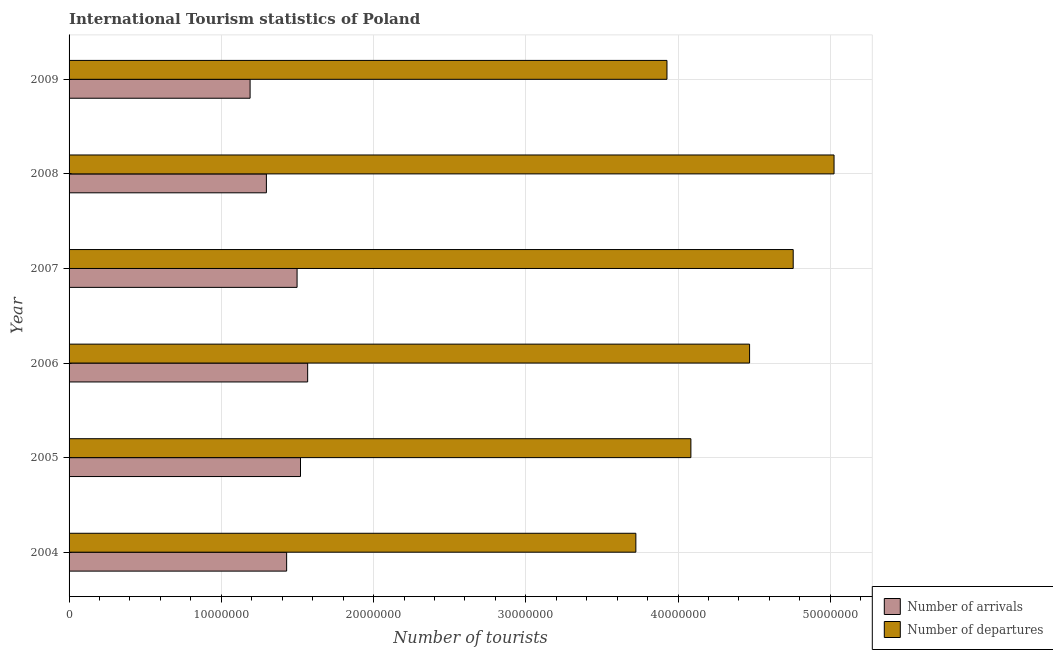How many different coloured bars are there?
Offer a terse response. 2. Are the number of bars on each tick of the Y-axis equal?
Your answer should be very brief. Yes. How many bars are there on the 3rd tick from the top?
Give a very brief answer. 2. What is the number of tourist departures in 2008?
Give a very brief answer. 5.02e+07. Across all years, what is the maximum number of tourist arrivals?
Your answer should be very brief. 1.57e+07. Across all years, what is the minimum number of tourist departures?
Offer a very short reply. 3.72e+07. In which year was the number of tourist arrivals maximum?
Offer a terse response. 2006. In which year was the number of tourist departures minimum?
Your response must be concise. 2004. What is the total number of tourist departures in the graph?
Ensure brevity in your answer.  2.60e+08. What is the difference between the number of tourist arrivals in 2007 and that in 2009?
Offer a very short reply. 3.08e+06. What is the difference between the number of tourist departures in 2008 and the number of tourist arrivals in 2009?
Provide a short and direct response. 3.84e+07. What is the average number of tourist arrivals per year?
Ensure brevity in your answer.  1.42e+07. In the year 2009, what is the difference between the number of tourist arrivals and number of tourist departures?
Offer a very short reply. -2.74e+07. In how many years, is the number of tourist departures greater than 12000000 ?
Make the answer very short. 6. What is the ratio of the number of tourist departures in 2004 to that in 2006?
Provide a short and direct response. 0.83. Is the number of tourist arrivals in 2008 less than that in 2009?
Provide a succinct answer. No. What is the difference between the highest and the second highest number of tourist departures?
Offer a very short reply. 2.68e+06. What is the difference between the highest and the lowest number of tourist arrivals?
Keep it short and to the point. 3.78e+06. Is the sum of the number of tourist departures in 2004 and 2007 greater than the maximum number of tourist arrivals across all years?
Keep it short and to the point. Yes. What does the 1st bar from the top in 2008 represents?
Give a very brief answer. Number of departures. What does the 2nd bar from the bottom in 2009 represents?
Make the answer very short. Number of departures. Are all the bars in the graph horizontal?
Your response must be concise. Yes. How many years are there in the graph?
Ensure brevity in your answer.  6. Are the values on the major ticks of X-axis written in scientific E-notation?
Give a very brief answer. No. Does the graph contain any zero values?
Give a very brief answer. No. Does the graph contain grids?
Make the answer very short. Yes. Where does the legend appear in the graph?
Your answer should be very brief. Bottom right. How many legend labels are there?
Your answer should be very brief. 2. How are the legend labels stacked?
Your answer should be compact. Vertical. What is the title of the graph?
Your response must be concise. International Tourism statistics of Poland. Does "From Government" appear as one of the legend labels in the graph?
Give a very brief answer. No. What is the label or title of the X-axis?
Your answer should be very brief. Number of tourists. What is the Number of tourists in Number of arrivals in 2004?
Offer a very short reply. 1.43e+07. What is the Number of tourists in Number of departures in 2004?
Give a very brief answer. 3.72e+07. What is the Number of tourists of Number of arrivals in 2005?
Keep it short and to the point. 1.52e+07. What is the Number of tourists in Number of departures in 2005?
Your answer should be very brief. 4.08e+07. What is the Number of tourists of Number of arrivals in 2006?
Give a very brief answer. 1.57e+07. What is the Number of tourists of Number of departures in 2006?
Your answer should be very brief. 4.47e+07. What is the Number of tourists of Number of arrivals in 2007?
Provide a succinct answer. 1.50e+07. What is the Number of tourists of Number of departures in 2007?
Provide a short and direct response. 4.76e+07. What is the Number of tourists of Number of arrivals in 2008?
Your answer should be compact. 1.30e+07. What is the Number of tourists in Number of departures in 2008?
Provide a short and direct response. 5.02e+07. What is the Number of tourists of Number of arrivals in 2009?
Offer a very short reply. 1.19e+07. What is the Number of tourists in Number of departures in 2009?
Make the answer very short. 3.93e+07. Across all years, what is the maximum Number of tourists of Number of arrivals?
Make the answer very short. 1.57e+07. Across all years, what is the maximum Number of tourists of Number of departures?
Your answer should be compact. 5.02e+07. Across all years, what is the minimum Number of tourists in Number of arrivals?
Offer a very short reply. 1.19e+07. Across all years, what is the minimum Number of tourists in Number of departures?
Keep it short and to the point. 3.72e+07. What is the total Number of tourists of Number of arrivals in the graph?
Give a very brief answer. 8.50e+07. What is the total Number of tourists of Number of departures in the graph?
Provide a short and direct response. 2.60e+08. What is the difference between the Number of tourists of Number of arrivals in 2004 and that in 2005?
Your response must be concise. -9.10e+05. What is the difference between the Number of tourists in Number of departures in 2004 and that in 2005?
Ensure brevity in your answer.  -3.62e+06. What is the difference between the Number of tourists in Number of arrivals in 2004 and that in 2006?
Provide a succinct answer. -1.38e+06. What is the difference between the Number of tourists in Number of departures in 2004 and that in 2006?
Your response must be concise. -7.47e+06. What is the difference between the Number of tourists of Number of arrivals in 2004 and that in 2007?
Your answer should be very brief. -6.85e+05. What is the difference between the Number of tourists of Number of departures in 2004 and that in 2007?
Make the answer very short. -1.03e+07. What is the difference between the Number of tourists of Number of arrivals in 2004 and that in 2008?
Keep it short and to the point. 1.33e+06. What is the difference between the Number of tourists of Number of departures in 2004 and that in 2008?
Your answer should be very brief. -1.30e+07. What is the difference between the Number of tourists in Number of arrivals in 2004 and that in 2009?
Offer a terse response. 2.40e+06. What is the difference between the Number of tourists in Number of departures in 2004 and that in 2009?
Provide a short and direct response. -2.04e+06. What is the difference between the Number of tourists of Number of arrivals in 2005 and that in 2006?
Your answer should be very brief. -4.70e+05. What is the difference between the Number of tourists of Number of departures in 2005 and that in 2006?
Your answer should be very brief. -3.86e+06. What is the difference between the Number of tourists of Number of arrivals in 2005 and that in 2007?
Provide a succinct answer. 2.25e+05. What is the difference between the Number of tourists in Number of departures in 2005 and that in 2007?
Provide a short and direct response. -6.72e+06. What is the difference between the Number of tourists of Number of arrivals in 2005 and that in 2008?
Keep it short and to the point. 2.24e+06. What is the difference between the Number of tourists in Number of departures in 2005 and that in 2008?
Ensure brevity in your answer.  -9.40e+06. What is the difference between the Number of tourists in Number of arrivals in 2005 and that in 2009?
Offer a terse response. 3.31e+06. What is the difference between the Number of tourists of Number of departures in 2005 and that in 2009?
Ensure brevity in your answer.  1.57e+06. What is the difference between the Number of tourists in Number of arrivals in 2006 and that in 2007?
Provide a succinct answer. 6.95e+05. What is the difference between the Number of tourists of Number of departures in 2006 and that in 2007?
Your answer should be very brief. -2.86e+06. What is the difference between the Number of tourists of Number of arrivals in 2006 and that in 2008?
Provide a short and direct response. 2.71e+06. What is the difference between the Number of tourists in Number of departures in 2006 and that in 2008?
Your answer should be compact. -5.55e+06. What is the difference between the Number of tourists in Number of arrivals in 2006 and that in 2009?
Ensure brevity in your answer.  3.78e+06. What is the difference between the Number of tourists of Number of departures in 2006 and that in 2009?
Your response must be concise. 5.43e+06. What is the difference between the Number of tourists in Number of arrivals in 2007 and that in 2008?
Provide a short and direct response. 2.02e+06. What is the difference between the Number of tourists in Number of departures in 2007 and that in 2008?
Offer a terse response. -2.68e+06. What is the difference between the Number of tourists in Number of arrivals in 2007 and that in 2009?
Ensure brevity in your answer.  3.08e+06. What is the difference between the Number of tourists in Number of departures in 2007 and that in 2009?
Offer a very short reply. 8.29e+06. What is the difference between the Number of tourists of Number of arrivals in 2008 and that in 2009?
Provide a short and direct response. 1.07e+06. What is the difference between the Number of tourists of Number of departures in 2008 and that in 2009?
Provide a short and direct response. 1.10e+07. What is the difference between the Number of tourists in Number of arrivals in 2004 and the Number of tourists in Number of departures in 2005?
Give a very brief answer. -2.66e+07. What is the difference between the Number of tourists of Number of arrivals in 2004 and the Number of tourists of Number of departures in 2006?
Keep it short and to the point. -3.04e+07. What is the difference between the Number of tourists in Number of arrivals in 2004 and the Number of tourists in Number of departures in 2007?
Give a very brief answer. -3.33e+07. What is the difference between the Number of tourists of Number of arrivals in 2004 and the Number of tourists of Number of departures in 2008?
Keep it short and to the point. -3.60e+07. What is the difference between the Number of tourists of Number of arrivals in 2004 and the Number of tourists of Number of departures in 2009?
Keep it short and to the point. -2.50e+07. What is the difference between the Number of tourists in Number of arrivals in 2005 and the Number of tourists in Number of departures in 2006?
Give a very brief answer. -2.95e+07. What is the difference between the Number of tourists in Number of arrivals in 2005 and the Number of tourists in Number of departures in 2007?
Keep it short and to the point. -3.24e+07. What is the difference between the Number of tourists of Number of arrivals in 2005 and the Number of tourists of Number of departures in 2008?
Keep it short and to the point. -3.50e+07. What is the difference between the Number of tourists of Number of arrivals in 2005 and the Number of tourists of Number of departures in 2009?
Provide a succinct answer. -2.41e+07. What is the difference between the Number of tourists of Number of arrivals in 2006 and the Number of tourists of Number of departures in 2007?
Your answer should be compact. -3.19e+07. What is the difference between the Number of tourists of Number of arrivals in 2006 and the Number of tourists of Number of departures in 2008?
Provide a short and direct response. -3.46e+07. What is the difference between the Number of tourists of Number of arrivals in 2006 and the Number of tourists of Number of departures in 2009?
Ensure brevity in your answer.  -2.36e+07. What is the difference between the Number of tourists of Number of arrivals in 2007 and the Number of tourists of Number of departures in 2008?
Offer a terse response. -3.53e+07. What is the difference between the Number of tourists of Number of arrivals in 2007 and the Number of tourists of Number of departures in 2009?
Give a very brief answer. -2.43e+07. What is the difference between the Number of tourists of Number of arrivals in 2008 and the Number of tourists of Number of departures in 2009?
Ensure brevity in your answer.  -2.63e+07. What is the average Number of tourists of Number of arrivals per year?
Make the answer very short. 1.42e+07. What is the average Number of tourists of Number of departures per year?
Ensure brevity in your answer.  4.33e+07. In the year 2004, what is the difference between the Number of tourists of Number of arrivals and Number of tourists of Number of departures?
Provide a short and direct response. -2.29e+07. In the year 2005, what is the difference between the Number of tourists of Number of arrivals and Number of tourists of Number of departures?
Provide a succinct answer. -2.56e+07. In the year 2006, what is the difference between the Number of tourists in Number of arrivals and Number of tourists in Number of departures?
Keep it short and to the point. -2.90e+07. In the year 2007, what is the difference between the Number of tourists of Number of arrivals and Number of tourists of Number of departures?
Keep it short and to the point. -3.26e+07. In the year 2008, what is the difference between the Number of tourists in Number of arrivals and Number of tourists in Number of departures?
Your response must be concise. -3.73e+07. In the year 2009, what is the difference between the Number of tourists in Number of arrivals and Number of tourists in Number of departures?
Your answer should be very brief. -2.74e+07. What is the ratio of the Number of tourists of Number of arrivals in 2004 to that in 2005?
Ensure brevity in your answer.  0.94. What is the ratio of the Number of tourists in Number of departures in 2004 to that in 2005?
Provide a short and direct response. 0.91. What is the ratio of the Number of tourists of Number of arrivals in 2004 to that in 2006?
Your response must be concise. 0.91. What is the ratio of the Number of tourists of Number of departures in 2004 to that in 2006?
Give a very brief answer. 0.83. What is the ratio of the Number of tourists of Number of arrivals in 2004 to that in 2007?
Your answer should be very brief. 0.95. What is the ratio of the Number of tourists of Number of departures in 2004 to that in 2007?
Your answer should be very brief. 0.78. What is the ratio of the Number of tourists in Number of arrivals in 2004 to that in 2008?
Give a very brief answer. 1.1. What is the ratio of the Number of tourists of Number of departures in 2004 to that in 2008?
Your answer should be compact. 0.74. What is the ratio of the Number of tourists of Number of arrivals in 2004 to that in 2009?
Ensure brevity in your answer.  1.2. What is the ratio of the Number of tourists of Number of departures in 2004 to that in 2009?
Your answer should be very brief. 0.95. What is the ratio of the Number of tourists of Number of arrivals in 2005 to that in 2006?
Your answer should be compact. 0.97. What is the ratio of the Number of tourists in Number of departures in 2005 to that in 2006?
Keep it short and to the point. 0.91. What is the ratio of the Number of tourists of Number of arrivals in 2005 to that in 2007?
Ensure brevity in your answer.  1.01. What is the ratio of the Number of tourists of Number of departures in 2005 to that in 2007?
Your answer should be very brief. 0.86. What is the ratio of the Number of tourists in Number of arrivals in 2005 to that in 2008?
Give a very brief answer. 1.17. What is the ratio of the Number of tourists in Number of departures in 2005 to that in 2008?
Keep it short and to the point. 0.81. What is the ratio of the Number of tourists in Number of arrivals in 2005 to that in 2009?
Your answer should be compact. 1.28. What is the ratio of the Number of tourists in Number of departures in 2005 to that in 2009?
Your answer should be very brief. 1.04. What is the ratio of the Number of tourists of Number of arrivals in 2006 to that in 2007?
Your answer should be very brief. 1.05. What is the ratio of the Number of tourists of Number of departures in 2006 to that in 2007?
Your response must be concise. 0.94. What is the ratio of the Number of tourists in Number of arrivals in 2006 to that in 2008?
Provide a succinct answer. 1.21. What is the ratio of the Number of tourists in Number of departures in 2006 to that in 2008?
Give a very brief answer. 0.89. What is the ratio of the Number of tourists in Number of arrivals in 2006 to that in 2009?
Provide a succinct answer. 1.32. What is the ratio of the Number of tourists of Number of departures in 2006 to that in 2009?
Your response must be concise. 1.14. What is the ratio of the Number of tourists in Number of arrivals in 2007 to that in 2008?
Provide a short and direct response. 1.16. What is the ratio of the Number of tourists in Number of departures in 2007 to that in 2008?
Your answer should be compact. 0.95. What is the ratio of the Number of tourists of Number of arrivals in 2007 to that in 2009?
Your response must be concise. 1.26. What is the ratio of the Number of tourists of Number of departures in 2007 to that in 2009?
Offer a terse response. 1.21. What is the ratio of the Number of tourists of Number of arrivals in 2008 to that in 2009?
Offer a very short reply. 1.09. What is the ratio of the Number of tourists of Number of departures in 2008 to that in 2009?
Ensure brevity in your answer.  1.28. What is the difference between the highest and the second highest Number of tourists in Number of arrivals?
Ensure brevity in your answer.  4.70e+05. What is the difference between the highest and the second highest Number of tourists in Number of departures?
Keep it short and to the point. 2.68e+06. What is the difference between the highest and the lowest Number of tourists in Number of arrivals?
Provide a succinct answer. 3.78e+06. What is the difference between the highest and the lowest Number of tourists in Number of departures?
Offer a terse response. 1.30e+07. 